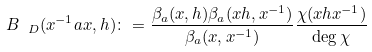Convert formula to latex. <formula><loc_0><loc_0><loc_500><loc_500>B _ { \ D } ( x ^ { - 1 } a x , h ) \colon = \frac { \beta _ { a } ( x , h ) \beta _ { a } ( x h , x ^ { - 1 } ) } { \beta _ { a } ( x , x ^ { - 1 } ) } \frac { \chi ( x h x ^ { - 1 } ) } { \deg \chi }</formula> 